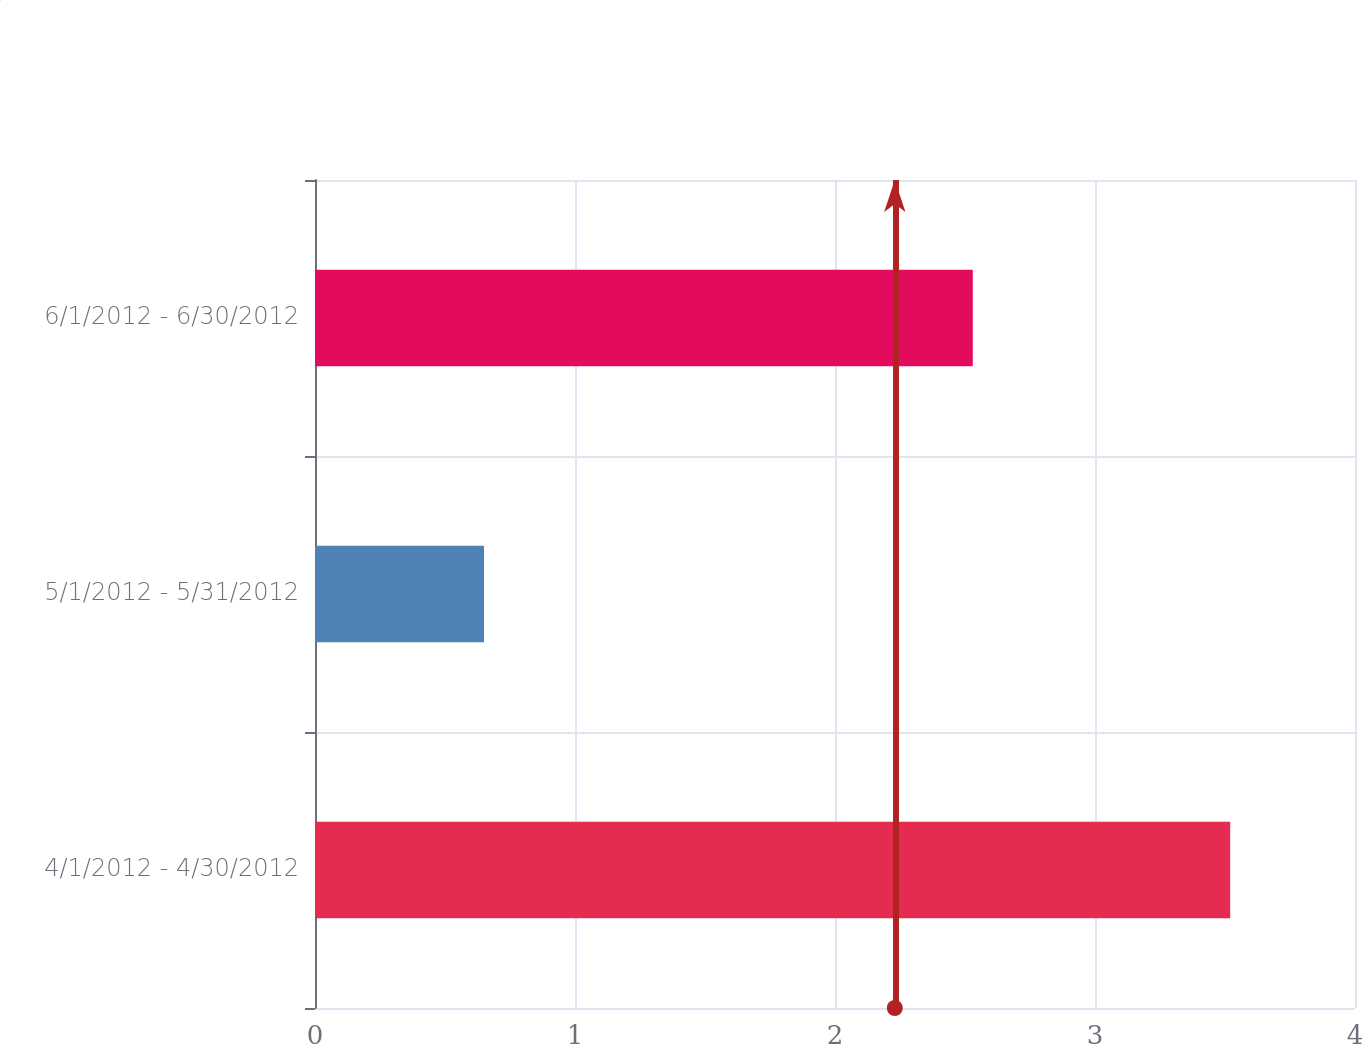Convert chart. <chart><loc_0><loc_0><loc_500><loc_500><bar_chart><fcel>4/1/2012 - 4/30/2012<fcel>5/1/2012 - 5/31/2012<fcel>6/1/2012 - 6/30/2012<nl><fcel>3.52<fcel>0.65<fcel>2.53<nl></chart> 